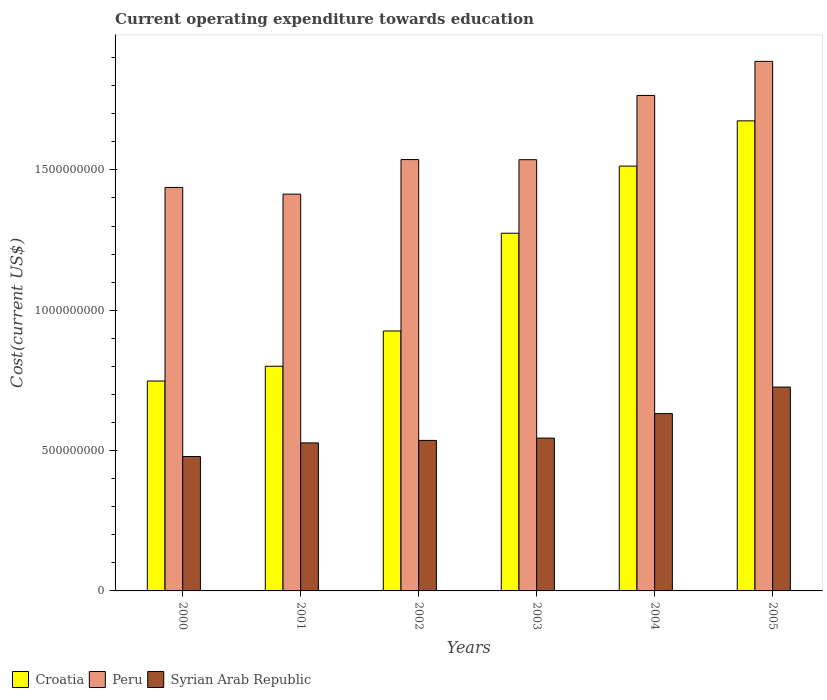How many different coloured bars are there?
Keep it short and to the point. 3. Are the number of bars on each tick of the X-axis equal?
Ensure brevity in your answer.  Yes. In how many cases, is the number of bars for a given year not equal to the number of legend labels?
Offer a terse response. 0. What is the expenditure towards education in Syrian Arab Republic in 2001?
Your response must be concise. 5.27e+08. Across all years, what is the maximum expenditure towards education in Croatia?
Keep it short and to the point. 1.67e+09. Across all years, what is the minimum expenditure towards education in Peru?
Your answer should be very brief. 1.41e+09. In which year was the expenditure towards education in Peru minimum?
Provide a succinct answer. 2001. What is the total expenditure towards education in Syrian Arab Republic in the graph?
Provide a succinct answer. 3.45e+09. What is the difference between the expenditure towards education in Peru in 2000 and that in 2001?
Offer a terse response. 2.38e+07. What is the difference between the expenditure towards education in Peru in 2005 and the expenditure towards education in Croatia in 2003?
Offer a terse response. 6.12e+08. What is the average expenditure towards education in Syrian Arab Republic per year?
Offer a terse response. 5.74e+08. In the year 2005, what is the difference between the expenditure towards education in Syrian Arab Republic and expenditure towards education in Croatia?
Provide a short and direct response. -9.49e+08. What is the ratio of the expenditure towards education in Syrian Arab Republic in 2003 to that in 2005?
Offer a very short reply. 0.75. Is the expenditure towards education in Syrian Arab Republic in 2001 less than that in 2003?
Give a very brief answer. Yes. Is the difference between the expenditure towards education in Syrian Arab Republic in 2002 and 2005 greater than the difference between the expenditure towards education in Croatia in 2002 and 2005?
Keep it short and to the point. Yes. What is the difference between the highest and the second highest expenditure towards education in Syrian Arab Republic?
Provide a succinct answer. 9.46e+07. What is the difference between the highest and the lowest expenditure towards education in Croatia?
Keep it short and to the point. 9.27e+08. In how many years, is the expenditure towards education in Peru greater than the average expenditure towards education in Peru taken over all years?
Offer a very short reply. 2. Is the sum of the expenditure towards education in Croatia in 2000 and 2002 greater than the maximum expenditure towards education in Syrian Arab Republic across all years?
Your answer should be compact. Yes. What does the 1st bar from the left in 2001 represents?
Provide a short and direct response. Croatia. What does the 1st bar from the right in 2003 represents?
Give a very brief answer. Syrian Arab Republic. How many bars are there?
Make the answer very short. 18. Are all the bars in the graph horizontal?
Your answer should be very brief. No. How many years are there in the graph?
Offer a terse response. 6. Are the values on the major ticks of Y-axis written in scientific E-notation?
Offer a very short reply. No. Does the graph contain any zero values?
Make the answer very short. No. How many legend labels are there?
Make the answer very short. 3. How are the legend labels stacked?
Make the answer very short. Horizontal. What is the title of the graph?
Offer a terse response. Current operating expenditure towards education. Does "Belize" appear as one of the legend labels in the graph?
Make the answer very short. No. What is the label or title of the Y-axis?
Your response must be concise. Cost(current US$). What is the Cost(current US$) in Croatia in 2000?
Your answer should be compact. 7.48e+08. What is the Cost(current US$) of Peru in 2000?
Keep it short and to the point. 1.44e+09. What is the Cost(current US$) of Syrian Arab Republic in 2000?
Provide a succinct answer. 4.79e+08. What is the Cost(current US$) in Croatia in 2001?
Offer a terse response. 8.00e+08. What is the Cost(current US$) of Peru in 2001?
Make the answer very short. 1.41e+09. What is the Cost(current US$) of Syrian Arab Republic in 2001?
Provide a short and direct response. 5.27e+08. What is the Cost(current US$) in Croatia in 2002?
Make the answer very short. 9.26e+08. What is the Cost(current US$) of Peru in 2002?
Provide a short and direct response. 1.54e+09. What is the Cost(current US$) of Syrian Arab Republic in 2002?
Your response must be concise. 5.36e+08. What is the Cost(current US$) of Croatia in 2003?
Provide a succinct answer. 1.27e+09. What is the Cost(current US$) in Peru in 2003?
Offer a terse response. 1.54e+09. What is the Cost(current US$) in Syrian Arab Republic in 2003?
Your answer should be very brief. 5.45e+08. What is the Cost(current US$) of Croatia in 2004?
Give a very brief answer. 1.51e+09. What is the Cost(current US$) in Peru in 2004?
Ensure brevity in your answer.  1.77e+09. What is the Cost(current US$) in Syrian Arab Republic in 2004?
Offer a very short reply. 6.32e+08. What is the Cost(current US$) in Croatia in 2005?
Make the answer very short. 1.67e+09. What is the Cost(current US$) of Peru in 2005?
Offer a terse response. 1.89e+09. What is the Cost(current US$) of Syrian Arab Republic in 2005?
Give a very brief answer. 7.26e+08. Across all years, what is the maximum Cost(current US$) in Croatia?
Give a very brief answer. 1.67e+09. Across all years, what is the maximum Cost(current US$) in Peru?
Your answer should be very brief. 1.89e+09. Across all years, what is the maximum Cost(current US$) of Syrian Arab Republic?
Ensure brevity in your answer.  7.26e+08. Across all years, what is the minimum Cost(current US$) of Croatia?
Ensure brevity in your answer.  7.48e+08. Across all years, what is the minimum Cost(current US$) in Peru?
Provide a succinct answer. 1.41e+09. Across all years, what is the minimum Cost(current US$) of Syrian Arab Republic?
Ensure brevity in your answer.  4.79e+08. What is the total Cost(current US$) in Croatia in the graph?
Your answer should be compact. 6.94e+09. What is the total Cost(current US$) of Peru in the graph?
Offer a very short reply. 9.58e+09. What is the total Cost(current US$) in Syrian Arab Republic in the graph?
Make the answer very short. 3.45e+09. What is the difference between the Cost(current US$) of Croatia in 2000 and that in 2001?
Your answer should be very brief. -5.26e+07. What is the difference between the Cost(current US$) of Peru in 2000 and that in 2001?
Your answer should be very brief. 2.38e+07. What is the difference between the Cost(current US$) in Syrian Arab Republic in 2000 and that in 2001?
Ensure brevity in your answer.  -4.86e+07. What is the difference between the Cost(current US$) in Croatia in 2000 and that in 2002?
Offer a terse response. -1.78e+08. What is the difference between the Cost(current US$) in Peru in 2000 and that in 2002?
Provide a short and direct response. -9.93e+07. What is the difference between the Cost(current US$) of Syrian Arab Republic in 2000 and that in 2002?
Offer a terse response. -5.74e+07. What is the difference between the Cost(current US$) of Croatia in 2000 and that in 2003?
Provide a short and direct response. -5.27e+08. What is the difference between the Cost(current US$) of Peru in 2000 and that in 2003?
Make the answer very short. -9.89e+07. What is the difference between the Cost(current US$) in Syrian Arab Republic in 2000 and that in 2003?
Ensure brevity in your answer.  -6.57e+07. What is the difference between the Cost(current US$) in Croatia in 2000 and that in 2004?
Provide a short and direct response. -7.66e+08. What is the difference between the Cost(current US$) in Peru in 2000 and that in 2004?
Offer a very short reply. -3.28e+08. What is the difference between the Cost(current US$) in Syrian Arab Republic in 2000 and that in 2004?
Offer a very short reply. -1.53e+08. What is the difference between the Cost(current US$) of Croatia in 2000 and that in 2005?
Ensure brevity in your answer.  -9.27e+08. What is the difference between the Cost(current US$) in Peru in 2000 and that in 2005?
Provide a short and direct response. -4.49e+08. What is the difference between the Cost(current US$) in Syrian Arab Republic in 2000 and that in 2005?
Offer a very short reply. -2.47e+08. What is the difference between the Cost(current US$) in Croatia in 2001 and that in 2002?
Make the answer very short. -1.26e+08. What is the difference between the Cost(current US$) of Peru in 2001 and that in 2002?
Your answer should be compact. -1.23e+08. What is the difference between the Cost(current US$) in Syrian Arab Republic in 2001 and that in 2002?
Give a very brief answer. -8.84e+06. What is the difference between the Cost(current US$) in Croatia in 2001 and that in 2003?
Provide a succinct answer. -4.74e+08. What is the difference between the Cost(current US$) of Peru in 2001 and that in 2003?
Keep it short and to the point. -1.23e+08. What is the difference between the Cost(current US$) in Syrian Arab Republic in 2001 and that in 2003?
Give a very brief answer. -1.71e+07. What is the difference between the Cost(current US$) of Croatia in 2001 and that in 2004?
Give a very brief answer. -7.13e+08. What is the difference between the Cost(current US$) in Peru in 2001 and that in 2004?
Provide a succinct answer. -3.52e+08. What is the difference between the Cost(current US$) in Syrian Arab Republic in 2001 and that in 2004?
Keep it short and to the point. -1.04e+08. What is the difference between the Cost(current US$) of Croatia in 2001 and that in 2005?
Give a very brief answer. -8.74e+08. What is the difference between the Cost(current US$) in Peru in 2001 and that in 2005?
Provide a succinct answer. -4.73e+08. What is the difference between the Cost(current US$) in Syrian Arab Republic in 2001 and that in 2005?
Make the answer very short. -1.99e+08. What is the difference between the Cost(current US$) in Croatia in 2002 and that in 2003?
Your answer should be very brief. -3.48e+08. What is the difference between the Cost(current US$) in Peru in 2002 and that in 2003?
Ensure brevity in your answer.  4.66e+05. What is the difference between the Cost(current US$) in Syrian Arab Republic in 2002 and that in 2003?
Your answer should be very brief. -8.27e+06. What is the difference between the Cost(current US$) of Croatia in 2002 and that in 2004?
Provide a short and direct response. -5.87e+08. What is the difference between the Cost(current US$) of Peru in 2002 and that in 2004?
Provide a succinct answer. -2.28e+08. What is the difference between the Cost(current US$) of Syrian Arab Republic in 2002 and that in 2004?
Provide a short and direct response. -9.54e+07. What is the difference between the Cost(current US$) in Croatia in 2002 and that in 2005?
Offer a very short reply. -7.49e+08. What is the difference between the Cost(current US$) in Peru in 2002 and that in 2005?
Your answer should be very brief. -3.50e+08. What is the difference between the Cost(current US$) of Syrian Arab Republic in 2002 and that in 2005?
Provide a short and direct response. -1.90e+08. What is the difference between the Cost(current US$) of Croatia in 2003 and that in 2004?
Your answer should be very brief. -2.39e+08. What is the difference between the Cost(current US$) in Peru in 2003 and that in 2004?
Your answer should be compact. -2.29e+08. What is the difference between the Cost(current US$) of Syrian Arab Republic in 2003 and that in 2004?
Make the answer very short. -8.72e+07. What is the difference between the Cost(current US$) in Croatia in 2003 and that in 2005?
Offer a terse response. -4.00e+08. What is the difference between the Cost(current US$) in Peru in 2003 and that in 2005?
Your answer should be very brief. -3.50e+08. What is the difference between the Cost(current US$) of Syrian Arab Republic in 2003 and that in 2005?
Provide a succinct answer. -1.82e+08. What is the difference between the Cost(current US$) of Croatia in 2004 and that in 2005?
Your response must be concise. -1.61e+08. What is the difference between the Cost(current US$) in Peru in 2004 and that in 2005?
Your response must be concise. -1.21e+08. What is the difference between the Cost(current US$) in Syrian Arab Republic in 2004 and that in 2005?
Your response must be concise. -9.46e+07. What is the difference between the Cost(current US$) of Croatia in 2000 and the Cost(current US$) of Peru in 2001?
Your response must be concise. -6.66e+08. What is the difference between the Cost(current US$) in Croatia in 2000 and the Cost(current US$) in Syrian Arab Republic in 2001?
Provide a succinct answer. 2.20e+08. What is the difference between the Cost(current US$) of Peru in 2000 and the Cost(current US$) of Syrian Arab Republic in 2001?
Your response must be concise. 9.10e+08. What is the difference between the Cost(current US$) of Croatia in 2000 and the Cost(current US$) of Peru in 2002?
Make the answer very short. -7.89e+08. What is the difference between the Cost(current US$) of Croatia in 2000 and the Cost(current US$) of Syrian Arab Republic in 2002?
Offer a terse response. 2.12e+08. What is the difference between the Cost(current US$) in Peru in 2000 and the Cost(current US$) in Syrian Arab Republic in 2002?
Keep it short and to the point. 9.01e+08. What is the difference between the Cost(current US$) of Croatia in 2000 and the Cost(current US$) of Peru in 2003?
Make the answer very short. -7.89e+08. What is the difference between the Cost(current US$) of Croatia in 2000 and the Cost(current US$) of Syrian Arab Republic in 2003?
Keep it short and to the point. 2.03e+08. What is the difference between the Cost(current US$) of Peru in 2000 and the Cost(current US$) of Syrian Arab Republic in 2003?
Provide a short and direct response. 8.93e+08. What is the difference between the Cost(current US$) of Croatia in 2000 and the Cost(current US$) of Peru in 2004?
Your response must be concise. -1.02e+09. What is the difference between the Cost(current US$) in Croatia in 2000 and the Cost(current US$) in Syrian Arab Republic in 2004?
Your response must be concise. 1.16e+08. What is the difference between the Cost(current US$) in Peru in 2000 and the Cost(current US$) in Syrian Arab Republic in 2004?
Your answer should be compact. 8.06e+08. What is the difference between the Cost(current US$) of Croatia in 2000 and the Cost(current US$) of Peru in 2005?
Your response must be concise. -1.14e+09. What is the difference between the Cost(current US$) of Croatia in 2000 and the Cost(current US$) of Syrian Arab Republic in 2005?
Give a very brief answer. 2.15e+07. What is the difference between the Cost(current US$) in Peru in 2000 and the Cost(current US$) in Syrian Arab Republic in 2005?
Your response must be concise. 7.11e+08. What is the difference between the Cost(current US$) in Croatia in 2001 and the Cost(current US$) in Peru in 2002?
Keep it short and to the point. -7.36e+08. What is the difference between the Cost(current US$) of Croatia in 2001 and the Cost(current US$) of Syrian Arab Republic in 2002?
Make the answer very short. 2.64e+08. What is the difference between the Cost(current US$) of Peru in 2001 and the Cost(current US$) of Syrian Arab Republic in 2002?
Offer a terse response. 8.77e+08. What is the difference between the Cost(current US$) of Croatia in 2001 and the Cost(current US$) of Peru in 2003?
Offer a very short reply. -7.36e+08. What is the difference between the Cost(current US$) in Croatia in 2001 and the Cost(current US$) in Syrian Arab Republic in 2003?
Give a very brief answer. 2.56e+08. What is the difference between the Cost(current US$) in Peru in 2001 and the Cost(current US$) in Syrian Arab Republic in 2003?
Ensure brevity in your answer.  8.69e+08. What is the difference between the Cost(current US$) of Croatia in 2001 and the Cost(current US$) of Peru in 2004?
Provide a short and direct response. -9.65e+08. What is the difference between the Cost(current US$) of Croatia in 2001 and the Cost(current US$) of Syrian Arab Republic in 2004?
Provide a short and direct response. 1.69e+08. What is the difference between the Cost(current US$) in Peru in 2001 and the Cost(current US$) in Syrian Arab Republic in 2004?
Offer a very short reply. 7.82e+08. What is the difference between the Cost(current US$) of Croatia in 2001 and the Cost(current US$) of Peru in 2005?
Ensure brevity in your answer.  -1.09e+09. What is the difference between the Cost(current US$) of Croatia in 2001 and the Cost(current US$) of Syrian Arab Republic in 2005?
Make the answer very short. 7.41e+07. What is the difference between the Cost(current US$) in Peru in 2001 and the Cost(current US$) in Syrian Arab Republic in 2005?
Provide a succinct answer. 6.87e+08. What is the difference between the Cost(current US$) of Croatia in 2002 and the Cost(current US$) of Peru in 2003?
Keep it short and to the point. -6.10e+08. What is the difference between the Cost(current US$) in Croatia in 2002 and the Cost(current US$) in Syrian Arab Republic in 2003?
Give a very brief answer. 3.82e+08. What is the difference between the Cost(current US$) in Peru in 2002 and the Cost(current US$) in Syrian Arab Republic in 2003?
Provide a succinct answer. 9.92e+08. What is the difference between the Cost(current US$) in Croatia in 2002 and the Cost(current US$) in Peru in 2004?
Your response must be concise. -8.39e+08. What is the difference between the Cost(current US$) of Croatia in 2002 and the Cost(current US$) of Syrian Arab Republic in 2004?
Offer a very short reply. 2.94e+08. What is the difference between the Cost(current US$) in Peru in 2002 and the Cost(current US$) in Syrian Arab Republic in 2004?
Keep it short and to the point. 9.05e+08. What is the difference between the Cost(current US$) of Croatia in 2002 and the Cost(current US$) of Peru in 2005?
Your answer should be very brief. -9.61e+08. What is the difference between the Cost(current US$) of Croatia in 2002 and the Cost(current US$) of Syrian Arab Republic in 2005?
Your response must be concise. 2.00e+08. What is the difference between the Cost(current US$) in Peru in 2002 and the Cost(current US$) in Syrian Arab Republic in 2005?
Your answer should be very brief. 8.11e+08. What is the difference between the Cost(current US$) in Croatia in 2003 and the Cost(current US$) in Peru in 2004?
Provide a short and direct response. -4.91e+08. What is the difference between the Cost(current US$) in Croatia in 2003 and the Cost(current US$) in Syrian Arab Republic in 2004?
Offer a terse response. 6.43e+08. What is the difference between the Cost(current US$) in Peru in 2003 and the Cost(current US$) in Syrian Arab Republic in 2004?
Give a very brief answer. 9.05e+08. What is the difference between the Cost(current US$) in Croatia in 2003 and the Cost(current US$) in Peru in 2005?
Offer a very short reply. -6.12e+08. What is the difference between the Cost(current US$) of Croatia in 2003 and the Cost(current US$) of Syrian Arab Republic in 2005?
Offer a terse response. 5.48e+08. What is the difference between the Cost(current US$) in Peru in 2003 and the Cost(current US$) in Syrian Arab Republic in 2005?
Your answer should be compact. 8.10e+08. What is the difference between the Cost(current US$) in Croatia in 2004 and the Cost(current US$) in Peru in 2005?
Make the answer very short. -3.73e+08. What is the difference between the Cost(current US$) in Croatia in 2004 and the Cost(current US$) in Syrian Arab Republic in 2005?
Offer a very short reply. 7.87e+08. What is the difference between the Cost(current US$) in Peru in 2004 and the Cost(current US$) in Syrian Arab Republic in 2005?
Your answer should be very brief. 1.04e+09. What is the average Cost(current US$) of Croatia per year?
Your answer should be compact. 1.16e+09. What is the average Cost(current US$) of Peru per year?
Provide a succinct answer. 1.60e+09. What is the average Cost(current US$) in Syrian Arab Republic per year?
Your response must be concise. 5.74e+08. In the year 2000, what is the difference between the Cost(current US$) in Croatia and Cost(current US$) in Peru?
Ensure brevity in your answer.  -6.90e+08. In the year 2000, what is the difference between the Cost(current US$) of Croatia and Cost(current US$) of Syrian Arab Republic?
Offer a very short reply. 2.69e+08. In the year 2000, what is the difference between the Cost(current US$) in Peru and Cost(current US$) in Syrian Arab Republic?
Ensure brevity in your answer.  9.59e+08. In the year 2001, what is the difference between the Cost(current US$) in Croatia and Cost(current US$) in Peru?
Offer a terse response. -6.13e+08. In the year 2001, what is the difference between the Cost(current US$) in Croatia and Cost(current US$) in Syrian Arab Republic?
Your response must be concise. 2.73e+08. In the year 2001, what is the difference between the Cost(current US$) of Peru and Cost(current US$) of Syrian Arab Republic?
Make the answer very short. 8.86e+08. In the year 2002, what is the difference between the Cost(current US$) in Croatia and Cost(current US$) in Peru?
Your answer should be very brief. -6.11e+08. In the year 2002, what is the difference between the Cost(current US$) of Croatia and Cost(current US$) of Syrian Arab Republic?
Your answer should be compact. 3.90e+08. In the year 2002, what is the difference between the Cost(current US$) in Peru and Cost(current US$) in Syrian Arab Republic?
Provide a succinct answer. 1.00e+09. In the year 2003, what is the difference between the Cost(current US$) of Croatia and Cost(current US$) of Peru?
Your answer should be very brief. -2.62e+08. In the year 2003, what is the difference between the Cost(current US$) in Croatia and Cost(current US$) in Syrian Arab Republic?
Make the answer very short. 7.30e+08. In the year 2003, what is the difference between the Cost(current US$) of Peru and Cost(current US$) of Syrian Arab Republic?
Give a very brief answer. 9.92e+08. In the year 2004, what is the difference between the Cost(current US$) of Croatia and Cost(current US$) of Peru?
Offer a very short reply. -2.52e+08. In the year 2004, what is the difference between the Cost(current US$) of Croatia and Cost(current US$) of Syrian Arab Republic?
Ensure brevity in your answer.  8.82e+08. In the year 2004, what is the difference between the Cost(current US$) of Peru and Cost(current US$) of Syrian Arab Republic?
Give a very brief answer. 1.13e+09. In the year 2005, what is the difference between the Cost(current US$) of Croatia and Cost(current US$) of Peru?
Keep it short and to the point. -2.12e+08. In the year 2005, what is the difference between the Cost(current US$) in Croatia and Cost(current US$) in Syrian Arab Republic?
Provide a short and direct response. 9.49e+08. In the year 2005, what is the difference between the Cost(current US$) of Peru and Cost(current US$) of Syrian Arab Republic?
Give a very brief answer. 1.16e+09. What is the ratio of the Cost(current US$) in Croatia in 2000 to that in 2001?
Ensure brevity in your answer.  0.93. What is the ratio of the Cost(current US$) in Peru in 2000 to that in 2001?
Your response must be concise. 1.02. What is the ratio of the Cost(current US$) in Syrian Arab Republic in 2000 to that in 2001?
Ensure brevity in your answer.  0.91. What is the ratio of the Cost(current US$) of Croatia in 2000 to that in 2002?
Give a very brief answer. 0.81. What is the ratio of the Cost(current US$) of Peru in 2000 to that in 2002?
Offer a terse response. 0.94. What is the ratio of the Cost(current US$) in Syrian Arab Republic in 2000 to that in 2002?
Keep it short and to the point. 0.89. What is the ratio of the Cost(current US$) of Croatia in 2000 to that in 2003?
Make the answer very short. 0.59. What is the ratio of the Cost(current US$) in Peru in 2000 to that in 2003?
Make the answer very short. 0.94. What is the ratio of the Cost(current US$) of Syrian Arab Republic in 2000 to that in 2003?
Provide a short and direct response. 0.88. What is the ratio of the Cost(current US$) in Croatia in 2000 to that in 2004?
Make the answer very short. 0.49. What is the ratio of the Cost(current US$) of Peru in 2000 to that in 2004?
Offer a terse response. 0.81. What is the ratio of the Cost(current US$) in Syrian Arab Republic in 2000 to that in 2004?
Offer a very short reply. 0.76. What is the ratio of the Cost(current US$) of Croatia in 2000 to that in 2005?
Your answer should be compact. 0.45. What is the ratio of the Cost(current US$) in Peru in 2000 to that in 2005?
Your response must be concise. 0.76. What is the ratio of the Cost(current US$) of Syrian Arab Republic in 2000 to that in 2005?
Offer a very short reply. 0.66. What is the ratio of the Cost(current US$) of Croatia in 2001 to that in 2002?
Make the answer very short. 0.86. What is the ratio of the Cost(current US$) of Peru in 2001 to that in 2002?
Your response must be concise. 0.92. What is the ratio of the Cost(current US$) in Syrian Arab Republic in 2001 to that in 2002?
Offer a very short reply. 0.98. What is the ratio of the Cost(current US$) in Croatia in 2001 to that in 2003?
Offer a terse response. 0.63. What is the ratio of the Cost(current US$) of Peru in 2001 to that in 2003?
Your answer should be very brief. 0.92. What is the ratio of the Cost(current US$) in Syrian Arab Republic in 2001 to that in 2003?
Ensure brevity in your answer.  0.97. What is the ratio of the Cost(current US$) of Croatia in 2001 to that in 2004?
Your answer should be compact. 0.53. What is the ratio of the Cost(current US$) in Peru in 2001 to that in 2004?
Keep it short and to the point. 0.8. What is the ratio of the Cost(current US$) in Syrian Arab Republic in 2001 to that in 2004?
Offer a terse response. 0.83. What is the ratio of the Cost(current US$) of Croatia in 2001 to that in 2005?
Ensure brevity in your answer.  0.48. What is the ratio of the Cost(current US$) of Peru in 2001 to that in 2005?
Make the answer very short. 0.75. What is the ratio of the Cost(current US$) in Syrian Arab Republic in 2001 to that in 2005?
Give a very brief answer. 0.73. What is the ratio of the Cost(current US$) of Croatia in 2002 to that in 2003?
Give a very brief answer. 0.73. What is the ratio of the Cost(current US$) in Peru in 2002 to that in 2003?
Ensure brevity in your answer.  1. What is the ratio of the Cost(current US$) in Syrian Arab Republic in 2002 to that in 2003?
Offer a terse response. 0.98. What is the ratio of the Cost(current US$) of Croatia in 2002 to that in 2004?
Offer a very short reply. 0.61. What is the ratio of the Cost(current US$) in Peru in 2002 to that in 2004?
Provide a succinct answer. 0.87. What is the ratio of the Cost(current US$) in Syrian Arab Republic in 2002 to that in 2004?
Provide a succinct answer. 0.85. What is the ratio of the Cost(current US$) of Croatia in 2002 to that in 2005?
Ensure brevity in your answer.  0.55. What is the ratio of the Cost(current US$) of Peru in 2002 to that in 2005?
Keep it short and to the point. 0.81. What is the ratio of the Cost(current US$) in Syrian Arab Republic in 2002 to that in 2005?
Keep it short and to the point. 0.74. What is the ratio of the Cost(current US$) in Croatia in 2003 to that in 2004?
Offer a terse response. 0.84. What is the ratio of the Cost(current US$) of Peru in 2003 to that in 2004?
Ensure brevity in your answer.  0.87. What is the ratio of the Cost(current US$) of Syrian Arab Republic in 2003 to that in 2004?
Ensure brevity in your answer.  0.86. What is the ratio of the Cost(current US$) of Croatia in 2003 to that in 2005?
Ensure brevity in your answer.  0.76. What is the ratio of the Cost(current US$) in Peru in 2003 to that in 2005?
Ensure brevity in your answer.  0.81. What is the ratio of the Cost(current US$) in Syrian Arab Republic in 2003 to that in 2005?
Give a very brief answer. 0.75. What is the ratio of the Cost(current US$) of Croatia in 2004 to that in 2005?
Ensure brevity in your answer.  0.9. What is the ratio of the Cost(current US$) in Peru in 2004 to that in 2005?
Your response must be concise. 0.94. What is the ratio of the Cost(current US$) in Syrian Arab Republic in 2004 to that in 2005?
Give a very brief answer. 0.87. What is the difference between the highest and the second highest Cost(current US$) of Croatia?
Give a very brief answer. 1.61e+08. What is the difference between the highest and the second highest Cost(current US$) in Peru?
Provide a short and direct response. 1.21e+08. What is the difference between the highest and the second highest Cost(current US$) of Syrian Arab Republic?
Your answer should be compact. 9.46e+07. What is the difference between the highest and the lowest Cost(current US$) of Croatia?
Your response must be concise. 9.27e+08. What is the difference between the highest and the lowest Cost(current US$) in Peru?
Provide a succinct answer. 4.73e+08. What is the difference between the highest and the lowest Cost(current US$) of Syrian Arab Republic?
Offer a very short reply. 2.47e+08. 